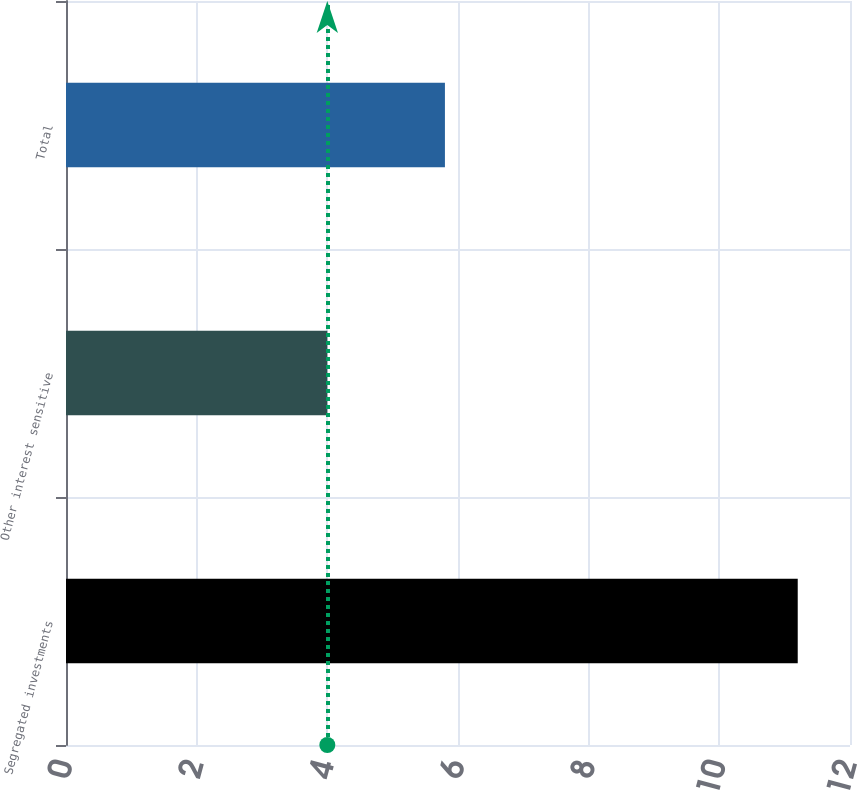<chart> <loc_0><loc_0><loc_500><loc_500><bar_chart><fcel>Segregated investments<fcel>Other interest sensitive<fcel>Total<nl><fcel>11.2<fcel>4<fcel>5.8<nl></chart> 